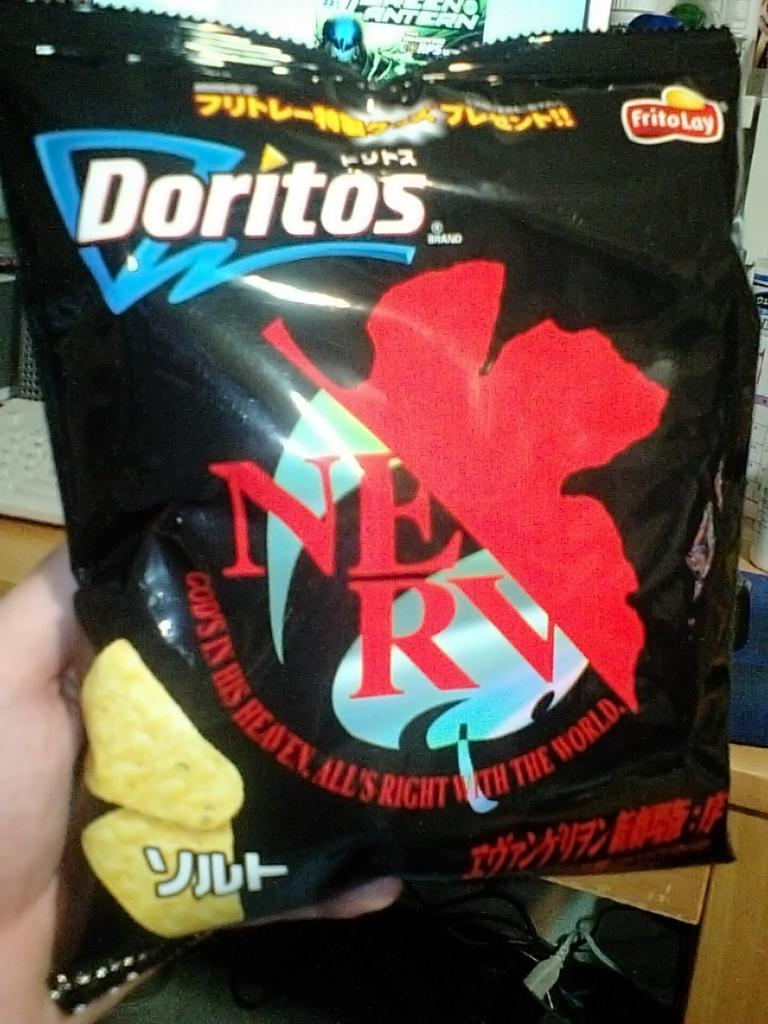What part of a person is visible on the left side of the image? There is a person's hand visible on the left side of the image. What is the person holding in their hand? The person is holding a packet. Can you describe the background of the image? There are objects in the background of the image. What type of whip is being used by the person in the image? There is no whip present in the image; the person is holding a packet. What crime is being committed in the image? There is no crime being committed in the image; it simply shows a person holding a packet. 